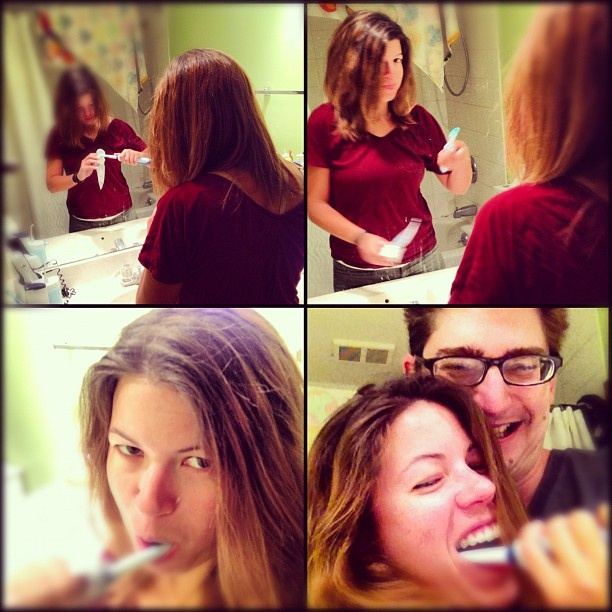Describe the objects in this image and their specific colors. I can see people in black, brown, maroon, and salmon tones, people in black, maroon, lightpink, brown, and tan tones, people in black, maroon, brown, and tan tones, people in black, purple, maroon, and brown tones, and people in black, maroon, brown, and salmon tones in this image. 